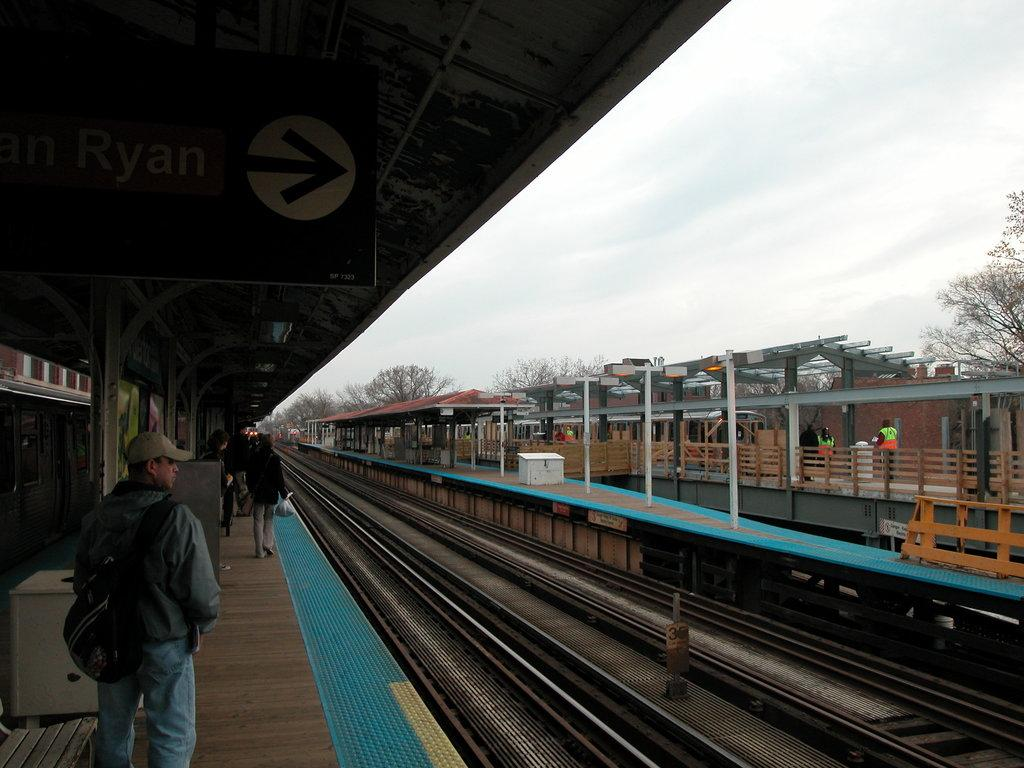What are the people in the image doing? There is a group of people walking in the image. What can be seen on the ground in the image? There are tracks visible in the image. What is located in the background of the image? There is railing and trees in the background of the image. What is the color of the sky in the image? The sky appears to be white in color. Is there a volcano visible in the image? No, there is no volcano present in the image. Does the existence of the group of people walking in the image prove the existence of land? The presence of the group of people walking in the image does not prove the existence of land, as it could be a photo taken on a bridge or other elevated structure. 